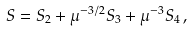<formula> <loc_0><loc_0><loc_500><loc_500>S = S _ { 2 } + \mu ^ { - 3 / 2 } S _ { 3 } + \mu ^ { - 3 } S _ { 4 } \, ,</formula> 